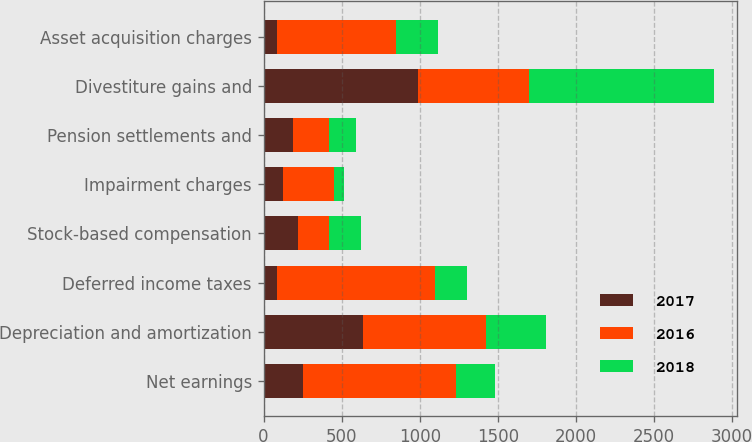Convert chart. <chart><loc_0><loc_0><loc_500><loc_500><stacked_bar_chart><ecel><fcel>Net earnings<fcel>Depreciation and amortization<fcel>Deferred income taxes<fcel>Stock-based compensation<fcel>Impairment charges<fcel>Pension settlements and<fcel>Divestiture gains and<fcel>Asset acquisition charges<nl><fcel>2017<fcel>255<fcel>637<fcel>86<fcel>221<fcel>126<fcel>186<fcel>992<fcel>85<nl><fcel>2016<fcel>975<fcel>789<fcel>1010<fcel>199<fcel>327<fcel>236<fcel>706<fcel>760<nl><fcel>2018<fcel>255<fcel>382<fcel>204<fcel>205<fcel>63<fcel>169<fcel>1187<fcel>274<nl></chart> 